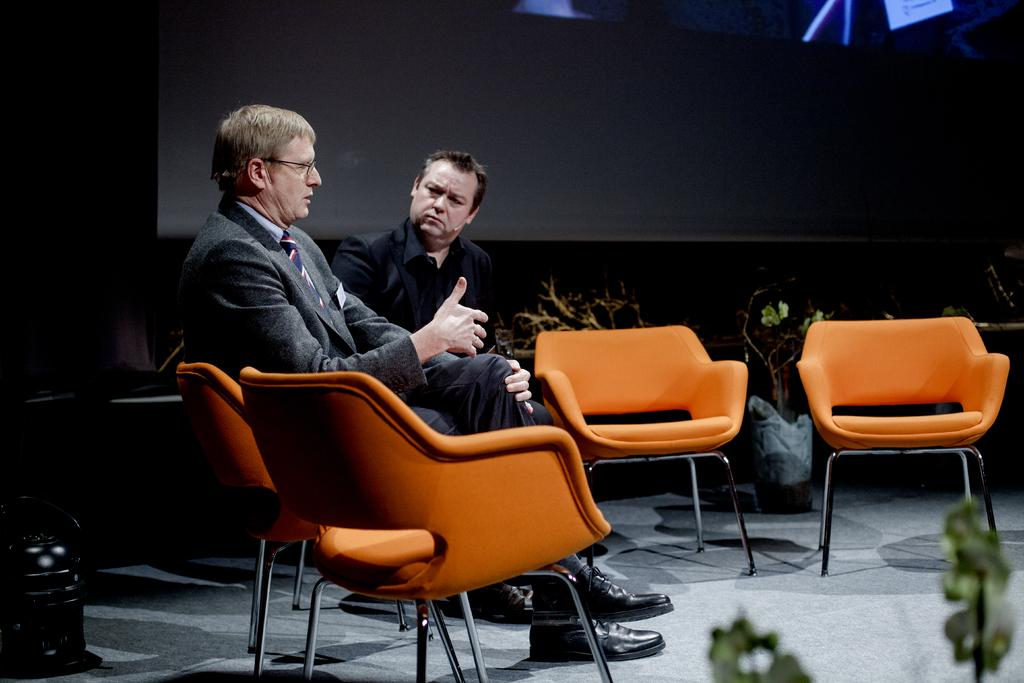How many people are in the image? There are two men in the image. What are the men sitting on? The men are sitting on orange chairs. What can be seen in the background of the image? There are plants and a projector display in the background of the image. What type of bread is being used to gain approval from the men in the image? There is no bread present in the image, and the men are not shown giving or receiving approval. 